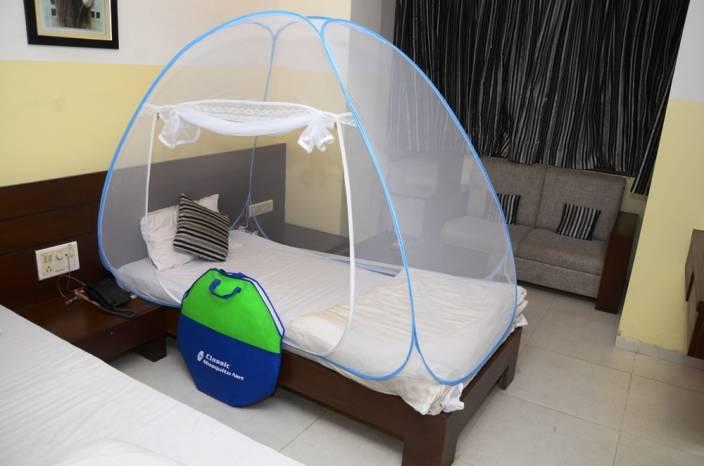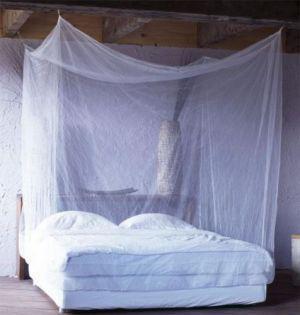The first image is the image on the left, the second image is the image on the right. For the images shown, is this caption "One of the beds has two pillows." true? Answer yes or no. Yes. 